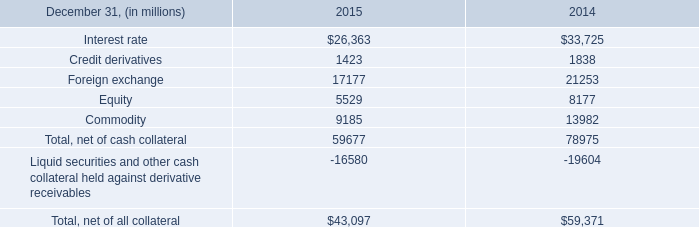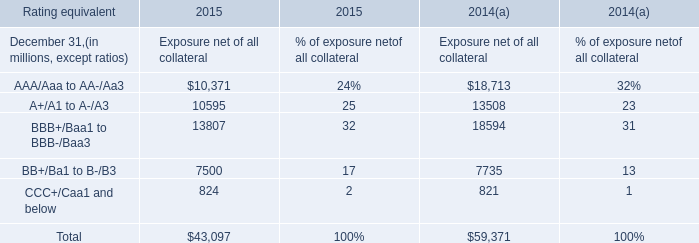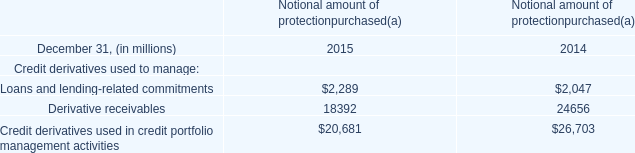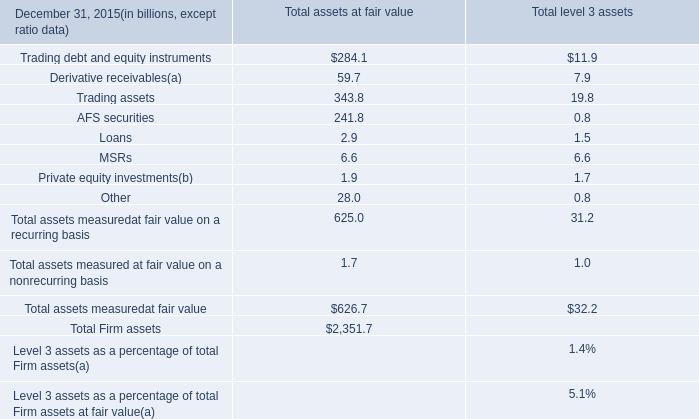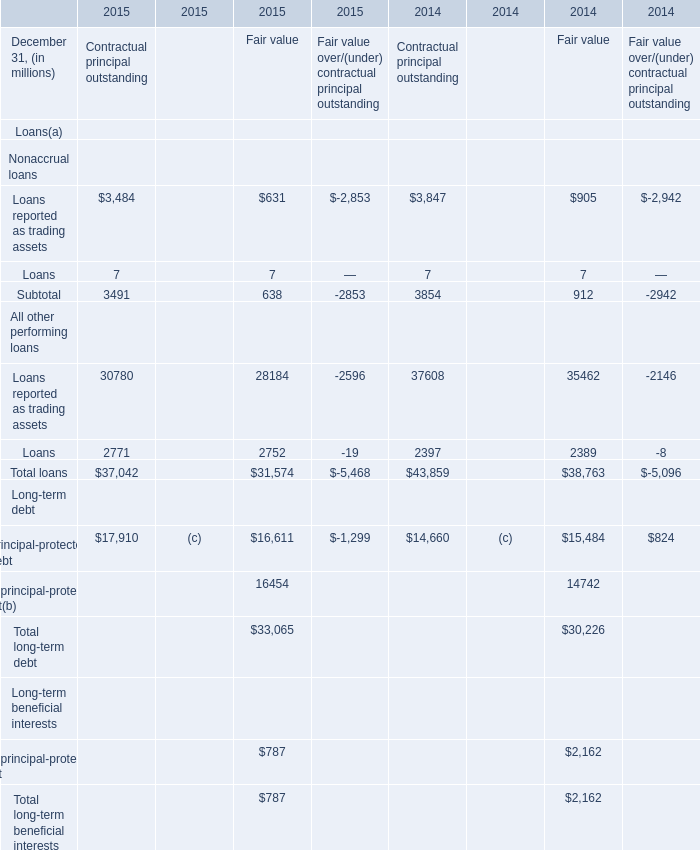what's the total amount of Interest rate of 2014, and Loans All other performing loans of 2015 Fair value ? 
Computations: (33725.0 + 2752.0)
Answer: 36477.0. 